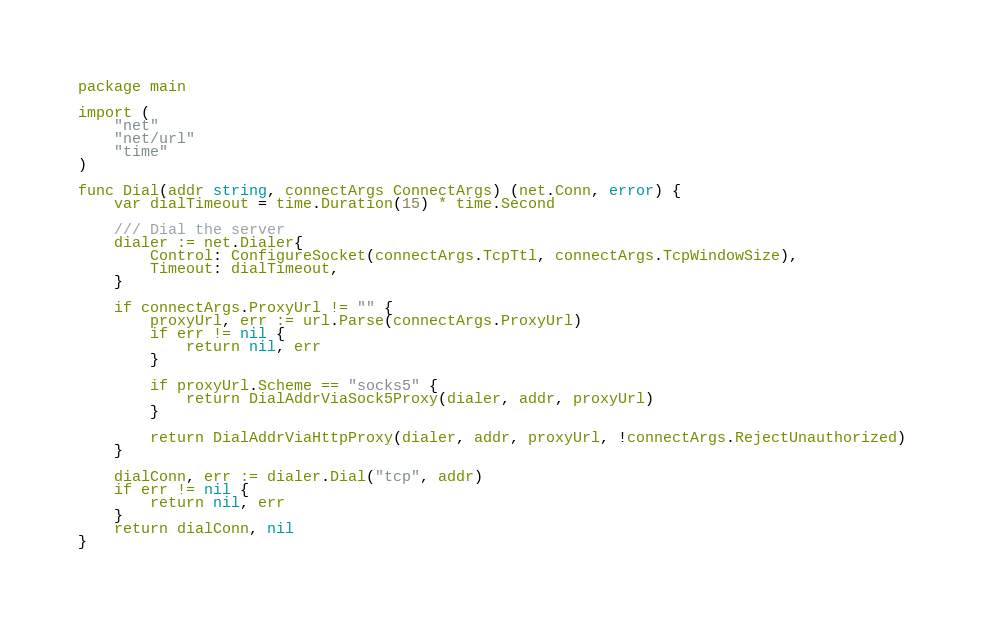Convert code to text. <code><loc_0><loc_0><loc_500><loc_500><_Go_>package main

import (
	"net"
	"net/url"
	"time"
)

func Dial(addr string, connectArgs ConnectArgs) (net.Conn, error) {
	var dialTimeout = time.Duration(15) * time.Second

	/// Dial the server
	dialer := net.Dialer{
		Control: ConfigureSocket(connectArgs.TcpTtl, connectArgs.TcpWindowSize),
		Timeout: dialTimeout,
	}

	if connectArgs.ProxyUrl != "" {
		proxyUrl, err := url.Parse(connectArgs.ProxyUrl)
		if err != nil {
			return nil, err
		}

		if proxyUrl.Scheme == "socks5" {
			return DialAddrViaSock5Proxy(dialer, addr, proxyUrl)
		}

		return DialAddrViaHttpProxy(dialer, addr, proxyUrl, !connectArgs.RejectUnauthorized)
	}

	dialConn, err := dialer.Dial("tcp", addr)
	if err != nil {
		return nil, err
	}
	return dialConn, nil
}
</code> 